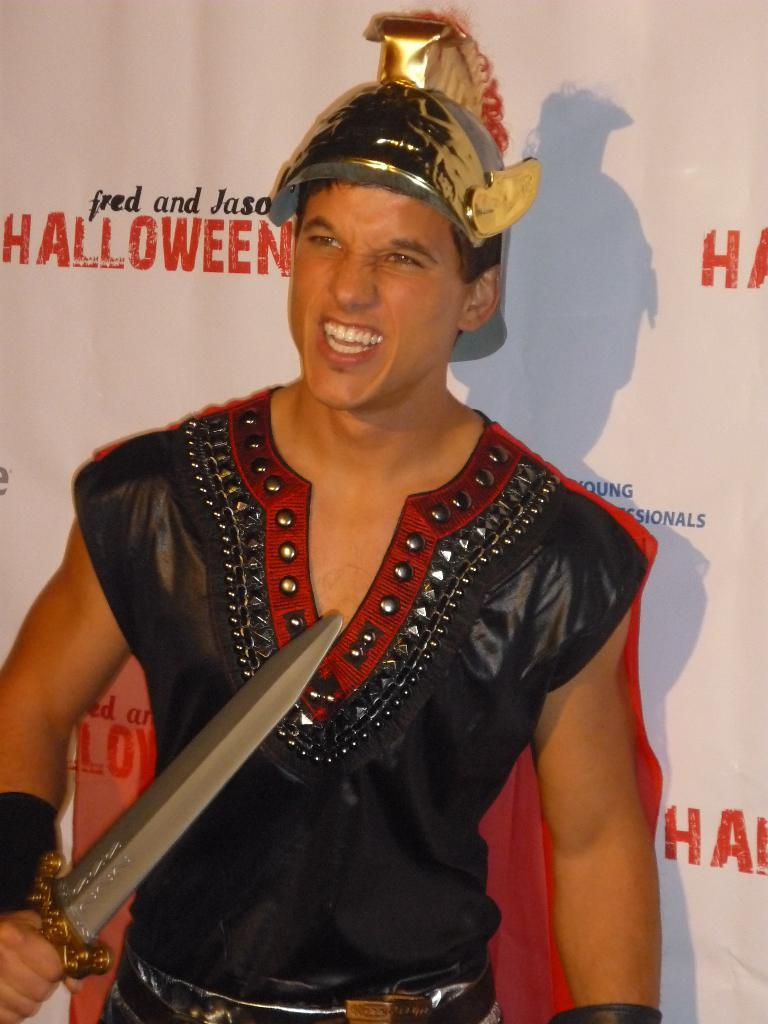Who is present in the image? There is a man in the image. What is the man wearing? The man is wearing a fancy dress. What object is the man holding? The man is holding a sword. What can be seen behind the man? There is a banner behind the man. What additional detail can be observed in the image? There is a shadow in the image. What type of food is the man eating in the image? There is no food present in the image; the man is holding a sword. What kind of lock can be seen on the banner in the image? There is no lock present on the banner in the image; it only features a design or text. 